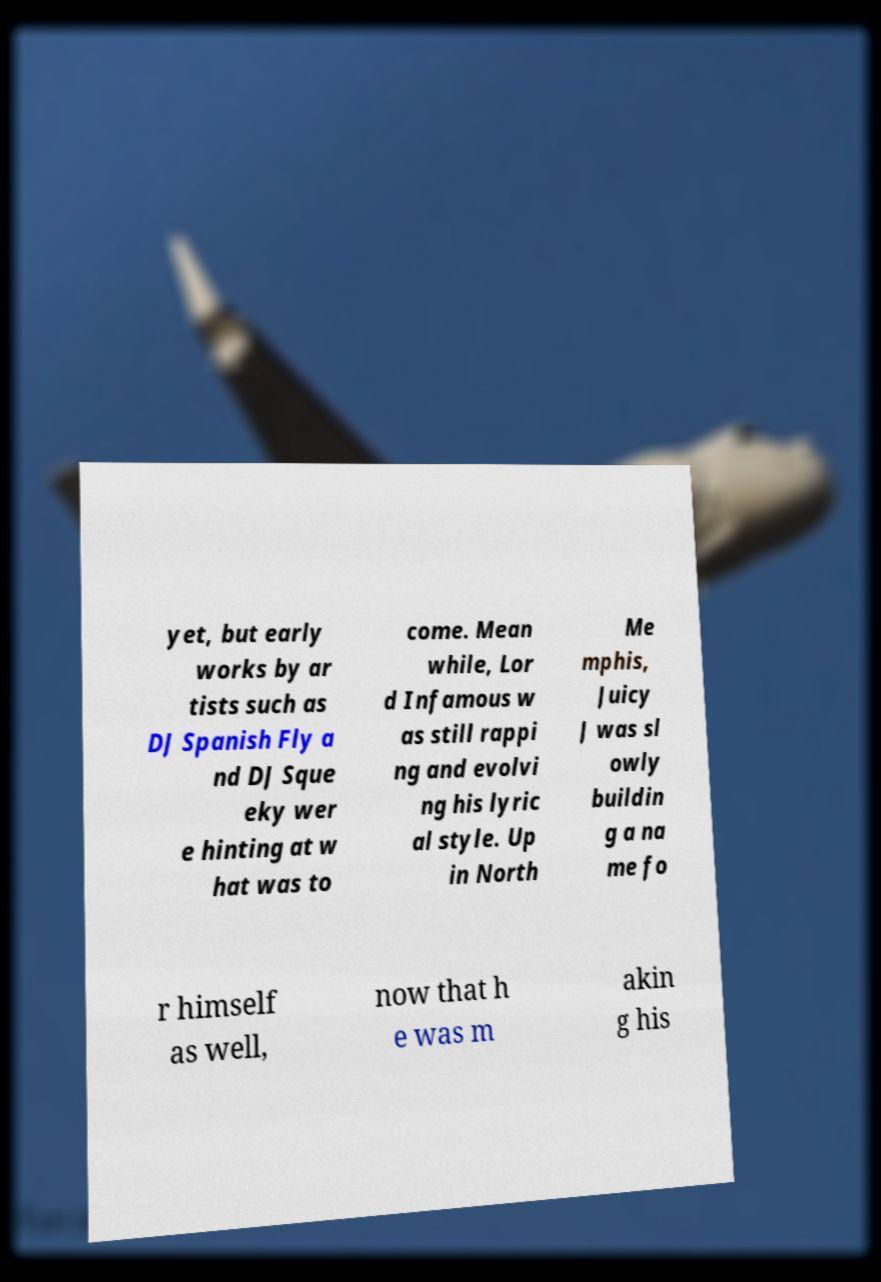Can you read and provide the text displayed in the image?This photo seems to have some interesting text. Can you extract and type it out for me? yet, but early works by ar tists such as DJ Spanish Fly a nd DJ Sque eky wer e hinting at w hat was to come. Mean while, Lor d Infamous w as still rappi ng and evolvi ng his lyric al style. Up in North Me mphis, Juicy J was sl owly buildin g a na me fo r himself as well, now that h e was m akin g his 